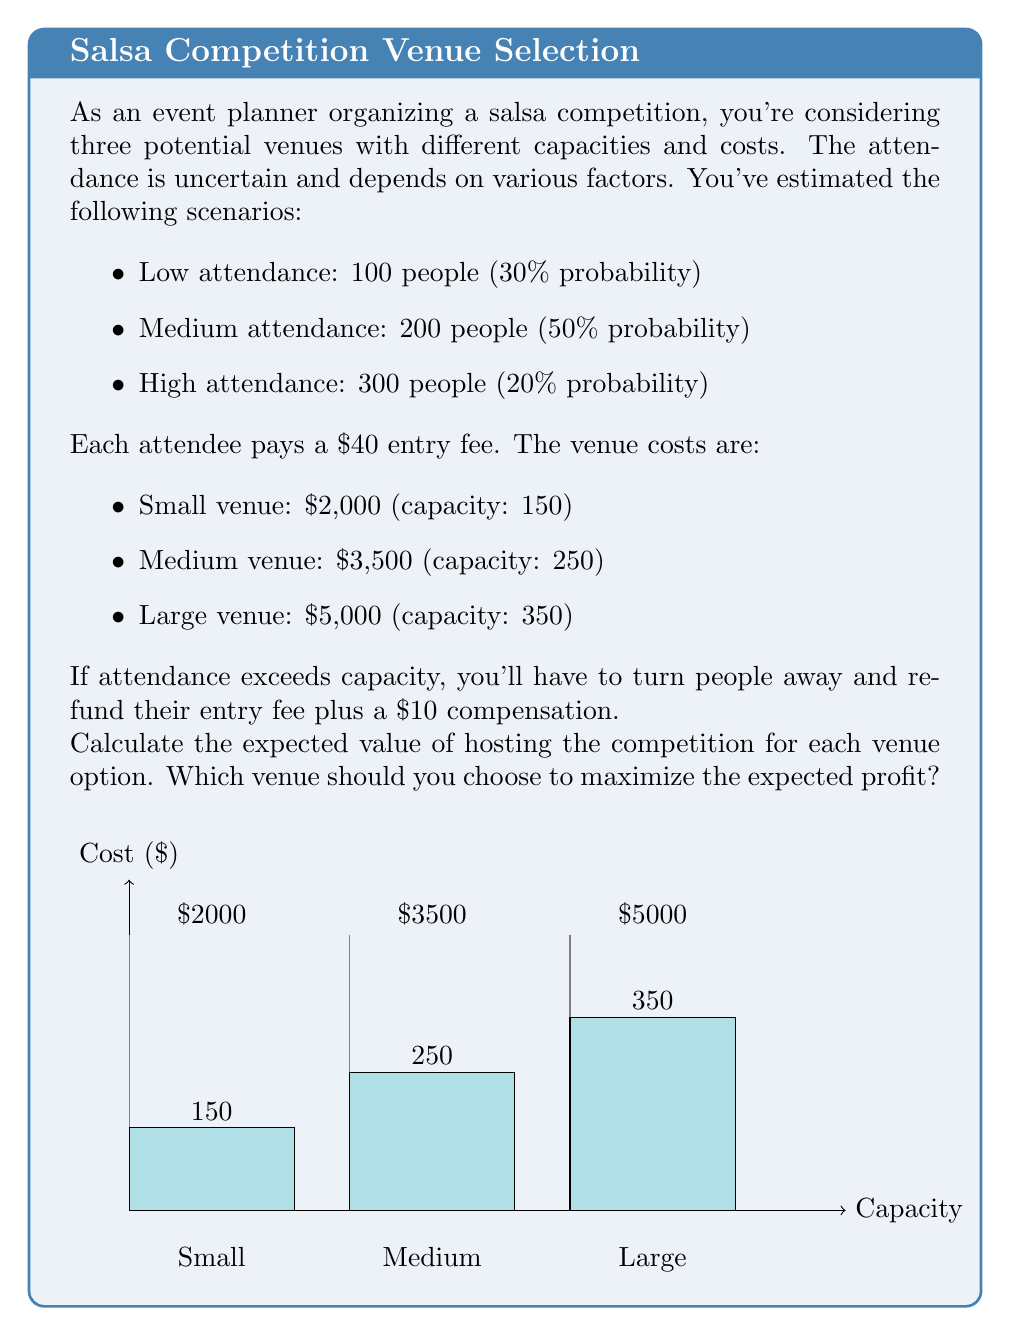Provide a solution to this math problem. Let's calculate the expected value for each venue:

1. Small Venue:
   - Low attendance: $100 * $40 - $2000 = $2000$
   - Medium attendance: $150 * $40 + (200 - 150) * (-$50) - $2000 = $3500$
   - High attendance: $150 * $40 + (300 - 150) * (-$50) - $2000 = $1000$

   Expected Value: $EV_S = 0.3 * $2000 + 0.5 * $3500 + 0.2 * $1000 = $2450$

2. Medium Venue:
   - Low attendance: $100 * $40 - $3500 = $500$
   - Medium attendance: $200 * $40 - $3500 = $4500$
   - High attendance: $250 * $40 + (300 - 250) * (-$50) - $3500 = $5750$

   Expected Value: $EV_M = 0.3 * $500 + 0.5 * $4500 + 0.2 * $5750 = $3400$

3. Large Venue:
   - Low attendance: $100 * $40 - $5000 = -$1000$
   - Medium attendance: $200 * $40 - $5000 = $3000$
   - High attendance: $300 * $40 - $5000 = $7000$

   Expected Value: $EV_L = 0.3 * (-$1000) + 0.5 * $3000 + 0.2 * $7000 = $2300$

The medium venue has the highest expected value at $3400.
Answer: Choose the medium venue; Expected Value = $3400 